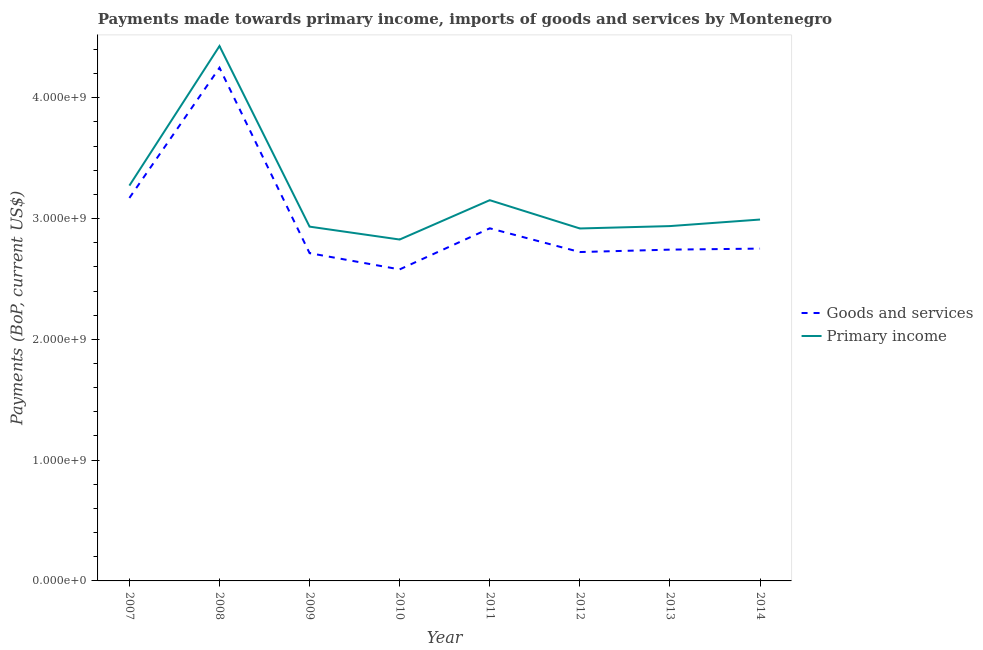What is the payments made towards primary income in 2008?
Your answer should be compact. 4.43e+09. Across all years, what is the maximum payments made towards goods and services?
Offer a terse response. 4.25e+09. Across all years, what is the minimum payments made towards goods and services?
Make the answer very short. 2.58e+09. What is the total payments made towards primary income in the graph?
Keep it short and to the point. 2.55e+1. What is the difference between the payments made towards goods and services in 2007 and that in 2008?
Provide a succinct answer. -1.08e+09. What is the difference between the payments made towards goods and services in 2013 and the payments made towards primary income in 2014?
Make the answer very short. -2.49e+08. What is the average payments made towards goods and services per year?
Provide a succinct answer. 2.98e+09. In the year 2013, what is the difference between the payments made towards primary income and payments made towards goods and services?
Keep it short and to the point. 1.95e+08. In how many years, is the payments made towards goods and services greater than 2200000000 US$?
Ensure brevity in your answer.  8. What is the ratio of the payments made towards goods and services in 2010 to that in 2013?
Your response must be concise. 0.94. What is the difference between the highest and the second highest payments made towards primary income?
Offer a very short reply. 1.16e+09. What is the difference between the highest and the lowest payments made towards goods and services?
Offer a very short reply. 1.67e+09. Does the payments made towards goods and services monotonically increase over the years?
Provide a short and direct response. No. How many lines are there?
Provide a short and direct response. 2. Are the values on the major ticks of Y-axis written in scientific E-notation?
Your response must be concise. Yes. How are the legend labels stacked?
Your answer should be compact. Vertical. What is the title of the graph?
Provide a succinct answer. Payments made towards primary income, imports of goods and services by Montenegro. Does "Netherlands" appear as one of the legend labels in the graph?
Make the answer very short. No. What is the label or title of the Y-axis?
Provide a short and direct response. Payments (BoP, current US$). What is the Payments (BoP, current US$) in Goods and services in 2007?
Keep it short and to the point. 3.17e+09. What is the Payments (BoP, current US$) in Primary income in 2007?
Keep it short and to the point. 3.27e+09. What is the Payments (BoP, current US$) in Goods and services in 2008?
Provide a short and direct response. 4.25e+09. What is the Payments (BoP, current US$) of Primary income in 2008?
Give a very brief answer. 4.43e+09. What is the Payments (BoP, current US$) in Goods and services in 2009?
Ensure brevity in your answer.  2.71e+09. What is the Payments (BoP, current US$) of Primary income in 2009?
Provide a succinct answer. 2.93e+09. What is the Payments (BoP, current US$) in Goods and services in 2010?
Your response must be concise. 2.58e+09. What is the Payments (BoP, current US$) of Primary income in 2010?
Keep it short and to the point. 2.83e+09. What is the Payments (BoP, current US$) of Goods and services in 2011?
Your response must be concise. 2.92e+09. What is the Payments (BoP, current US$) in Primary income in 2011?
Keep it short and to the point. 3.15e+09. What is the Payments (BoP, current US$) of Goods and services in 2012?
Make the answer very short. 2.72e+09. What is the Payments (BoP, current US$) in Primary income in 2012?
Provide a short and direct response. 2.92e+09. What is the Payments (BoP, current US$) of Goods and services in 2013?
Your answer should be compact. 2.74e+09. What is the Payments (BoP, current US$) in Primary income in 2013?
Make the answer very short. 2.94e+09. What is the Payments (BoP, current US$) of Goods and services in 2014?
Give a very brief answer. 2.75e+09. What is the Payments (BoP, current US$) in Primary income in 2014?
Your answer should be compact. 2.99e+09. Across all years, what is the maximum Payments (BoP, current US$) in Goods and services?
Make the answer very short. 4.25e+09. Across all years, what is the maximum Payments (BoP, current US$) of Primary income?
Provide a short and direct response. 4.43e+09. Across all years, what is the minimum Payments (BoP, current US$) of Goods and services?
Give a very brief answer. 2.58e+09. Across all years, what is the minimum Payments (BoP, current US$) in Primary income?
Provide a succinct answer. 2.83e+09. What is the total Payments (BoP, current US$) in Goods and services in the graph?
Your answer should be very brief. 2.38e+1. What is the total Payments (BoP, current US$) of Primary income in the graph?
Give a very brief answer. 2.55e+1. What is the difference between the Payments (BoP, current US$) in Goods and services in 2007 and that in 2008?
Give a very brief answer. -1.08e+09. What is the difference between the Payments (BoP, current US$) of Primary income in 2007 and that in 2008?
Keep it short and to the point. -1.16e+09. What is the difference between the Payments (BoP, current US$) of Goods and services in 2007 and that in 2009?
Give a very brief answer. 4.57e+08. What is the difference between the Payments (BoP, current US$) of Primary income in 2007 and that in 2009?
Ensure brevity in your answer.  3.40e+08. What is the difference between the Payments (BoP, current US$) of Goods and services in 2007 and that in 2010?
Provide a succinct answer. 5.92e+08. What is the difference between the Payments (BoP, current US$) in Primary income in 2007 and that in 2010?
Offer a very short reply. 4.46e+08. What is the difference between the Payments (BoP, current US$) in Goods and services in 2007 and that in 2011?
Provide a succinct answer. 2.51e+08. What is the difference between the Payments (BoP, current US$) in Primary income in 2007 and that in 2011?
Keep it short and to the point. 1.21e+08. What is the difference between the Payments (BoP, current US$) of Goods and services in 2007 and that in 2012?
Your answer should be very brief. 4.48e+08. What is the difference between the Payments (BoP, current US$) of Primary income in 2007 and that in 2012?
Your answer should be very brief. 3.55e+08. What is the difference between the Payments (BoP, current US$) in Goods and services in 2007 and that in 2013?
Offer a very short reply. 4.28e+08. What is the difference between the Payments (BoP, current US$) in Primary income in 2007 and that in 2013?
Offer a very short reply. 3.35e+08. What is the difference between the Payments (BoP, current US$) in Goods and services in 2007 and that in 2014?
Your response must be concise. 4.19e+08. What is the difference between the Payments (BoP, current US$) of Primary income in 2007 and that in 2014?
Give a very brief answer. 2.81e+08. What is the difference between the Payments (BoP, current US$) in Goods and services in 2008 and that in 2009?
Give a very brief answer. 1.53e+09. What is the difference between the Payments (BoP, current US$) of Primary income in 2008 and that in 2009?
Offer a very short reply. 1.50e+09. What is the difference between the Payments (BoP, current US$) in Goods and services in 2008 and that in 2010?
Make the answer very short. 1.67e+09. What is the difference between the Payments (BoP, current US$) in Primary income in 2008 and that in 2010?
Your response must be concise. 1.60e+09. What is the difference between the Payments (BoP, current US$) in Goods and services in 2008 and that in 2011?
Ensure brevity in your answer.  1.33e+09. What is the difference between the Payments (BoP, current US$) of Primary income in 2008 and that in 2011?
Provide a succinct answer. 1.28e+09. What is the difference between the Payments (BoP, current US$) in Goods and services in 2008 and that in 2012?
Keep it short and to the point. 1.53e+09. What is the difference between the Payments (BoP, current US$) in Primary income in 2008 and that in 2012?
Give a very brief answer. 1.51e+09. What is the difference between the Payments (BoP, current US$) in Goods and services in 2008 and that in 2013?
Provide a succinct answer. 1.51e+09. What is the difference between the Payments (BoP, current US$) in Primary income in 2008 and that in 2013?
Your response must be concise. 1.49e+09. What is the difference between the Payments (BoP, current US$) in Goods and services in 2008 and that in 2014?
Your response must be concise. 1.50e+09. What is the difference between the Payments (BoP, current US$) in Primary income in 2008 and that in 2014?
Provide a succinct answer. 1.44e+09. What is the difference between the Payments (BoP, current US$) of Goods and services in 2009 and that in 2010?
Ensure brevity in your answer.  1.34e+08. What is the difference between the Payments (BoP, current US$) of Primary income in 2009 and that in 2010?
Give a very brief answer. 1.07e+08. What is the difference between the Payments (BoP, current US$) of Goods and services in 2009 and that in 2011?
Provide a short and direct response. -2.06e+08. What is the difference between the Payments (BoP, current US$) of Primary income in 2009 and that in 2011?
Offer a very short reply. -2.19e+08. What is the difference between the Payments (BoP, current US$) in Goods and services in 2009 and that in 2012?
Provide a short and direct response. -9.23e+06. What is the difference between the Payments (BoP, current US$) in Primary income in 2009 and that in 2012?
Ensure brevity in your answer.  1.51e+07. What is the difference between the Payments (BoP, current US$) of Goods and services in 2009 and that in 2013?
Your response must be concise. -2.92e+07. What is the difference between the Payments (BoP, current US$) in Primary income in 2009 and that in 2013?
Make the answer very short. -4.58e+06. What is the difference between the Payments (BoP, current US$) of Goods and services in 2009 and that in 2014?
Make the answer very short. -3.77e+07. What is the difference between the Payments (BoP, current US$) in Primary income in 2009 and that in 2014?
Offer a terse response. -5.88e+07. What is the difference between the Payments (BoP, current US$) of Goods and services in 2010 and that in 2011?
Your response must be concise. -3.40e+08. What is the difference between the Payments (BoP, current US$) in Primary income in 2010 and that in 2011?
Keep it short and to the point. -3.26e+08. What is the difference between the Payments (BoP, current US$) in Goods and services in 2010 and that in 2012?
Keep it short and to the point. -1.44e+08. What is the difference between the Payments (BoP, current US$) of Primary income in 2010 and that in 2012?
Offer a terse response. -9.16e+07. What is the difference between the Payments (BoP, current US$) in Goods and services in 2010 and that in 2013?
Your answer should be compact. -1.64e+08. What is the difference between the Payments (BoP, current US$) in Primary income in 2010 and that in 2013?
Your answer should be very brief. -1.11e+08. What is the difference between the Payments (BoP, current US$) of Goods and services in 2010 and that in 2014?
Provide a short and direct response. -1.72e+08. What is the difference between the Payments (BoP, current US$) of Primary income in 2010 and that in 2014?
Provide a succinct answer. -1.66e+08. What is the difference between the Payments (BoP, current US$) in Goods and services in 2011 and that in 2012?
Keep it short and to the point. 1.96e+08. What is the difference between the Payments (BoP, current US$) of Primary income in 2011 and that in 2012?
Offer a terse response. 2.34e+08. What is the difference between the Payments (BoP, current US$) in Goods and services in 2011 and that in 2013?
Ensure brevity in your answer.  1.77e+08. What is the difference between the Payments (BoP, current US$) of Primary income in 2011 and that in 2013?
Your response must be concise. 2.14e+08. What is the difference between the Payments (BoP, current US$) in Goods and services in 2011 and that in 2014?
Keep it short and to the point. 1.68e+08. What is the difference between the Payments (BoP, current US$) in Primary income in 2011 and that in 2014?
Provide a succinct answer. 1.60e+08. What is the difference between the Payments (BoP, current US$) in Goods and services in 2012 and that in 2013?
Your response must be concise. -1.99e+07. What is the difference between the Payments (BoP, current US$) of Primary income in 2012 and that in 2013?
Offer a terse response. -1.97e+07. What is the difference between the Payments (BoP, current US$) of Goods and services in 2012 and that in 2014?
Keep it short and to the point. -2.85e+07. What is the difference between the Payments (BoP, current US$) of Primary income in 2012 and that in 2014?
Ensure brevity in your answer.  -7.39e+07. What is the difference between the Payments (BoP, current US$) in Goods and services in 2013 and that in 2014?
Your response must be concise. -8.57e+06. What is the difference between the Payments (BoP, current US$) in Primary income in 2013 and that in 2014?
Make the answer very short. -5.42e+07. What is the difference between the Payments (BoP, current US$) of Goods and services in 2007 and the Payments (BoP, current US$) of Primary income in 2008?
Your response must be concise. -1.26e+09. What is the difference between the Payments (BoP, current US$) of Goods and services in 2007 and the Payments (BoP, current US$) of Primary income in 2009?
Provide a succinct answer. 2.38e+08. What is the difference between the Payments (BoP, current US$) in Goods and services in 2007 and the Payments (BoP, current US$) in Primary income in 2010?
Make the answer very short. 3.44e+08. What is the difference between the Payments (BoP, current US$) in Goods and services in 2007 and the Payments (BoP, current US$) in Primary income in 2011?
Offer a very short reply. 1.85e+07. What is the difference between the Payments (BoP, current US$) of Goods and services in 2007 and the Payments (BoP, current US$) of Primary income in 2012?
Offer a terse response. 2.53e+08. What is the difference between the Payments (BoP, current US$) in Goods and services in 2007 and the Payments (BoP, current US$) in Primary income in 2013?
Give a very brief answer. 2.33e+08. What is the difference between the Payments (BoP, current US$) in Goods and services in 2007 and the Payments (BoP, current US$) in Primary income in 2014?
Provide a short and direct response. 1.79e+08. What is the difference between the Payments (BoP, current US$) in Goods and services in 2008 and the Payments (BoP, current US$) in Primary income in 2009?
Your answer should be very brief. 1.32e+09. What is the difference between the Payments (BoP, current US$) in Goods and services in 2008 and the Payments (BoP, current US$) in Primary income in 2010?
Your answer should be compact. 1.42e+09. What is the difference between the Payments (BoP, current US$) of Goods and services in 2008 and the Payments (BoP, current US$) of Primary income in 2011?
Provide a succinct answer. 1.10e+09. What is the difference between the Payments (BoP, current US$) of Goods and services in 2008 and the Payments (BoP, current US$) of Primary income in 2012?
Make the answer very short. 1.33e+09. What is the difference between the Payments (BoP, current US$) of Goods and services in 2008 and the Payments (BoP, current US$) of Primary income in 2013?
Provide a succinct answer. 1.31e+09. What is the difference between the Payments (BoP, current US$) in Goods and services in 2008 and the Payments (BoP, current US$) in Primary income in 2014?
Provide a succinct answer. 1.26e+09. What is the difference between the Payments (BoP, current US$) in Goods and services in 2009 and the Payments (BoP, current US$) in Primary income in 2010?
Your answer should be very brief. -1.13e+08. What is the difference between the Payments (BoP, current US$) in Goods and services in 2009 and the Payments (BoP, current US$) in Primary income in 2011?
Offer a very short reply. -4.39e+08. What is the difference between the Payments (BoP, current US$) in Goods and services in 2009 and the Payments (BoP, current US$) in Primary income in 2012?
Provide a short and direct response. -2.04e+08. What is the difference between the Payments (BoP, current US$) of Goods and services in 2009 and the Payments (BoP, current US$) of Primary income in 2013?
Give a very brief answer. -2.24e+08. What is the difference between the Payments (BoP, current US$) of Goods and services in 2009 and the Payments (BoP, current US$) of Primary income in 2014?
Give a very brief answer. -2.78e+08. What is the difference between the Payments (BoP, current US$) of Goods and services in 2010 and the Payments (BoP, current US$) of Primary income in 2011?
Make the answer very short. -5.73e+08. What is the difference between the Payments (BoP, current US$) in Goods and services in 2010 and the Payments (BoP, current US$) in Primary income in 2012?
Offer a very short reply. -3.39e+08. What is the difference between the Payments (BoP, current US$) of Goods and services in 2010 and the Payments (BoP, current US$) of Primary income in 2013?
Give a very brief answer. -3.59e+08. What is the difference between the Payments (BoP, current US$) in Goods and services in 2010 and the Payments (BoP, current US$) in Primary income in 2014?
Your answer should be very brief. -4.13e+08. What is the difference between the Payments (BoP, current US$) of Goods and services in 2011 and the Payments (BoP, current US$) of Primary income in 2012?
Offer a very short reply. 1.32e+06. What is the difference between the Payments (BoP, current US$) of Goods and services in 2011 and the Payments (BoP, current US$) of Primary income in 2013?
Ensure brevity in your answer.  -1.84e+07. What is the difference between the Payments (BoP, current US$) in Goods and services in 2011 and the Payments (BoP, current US$) in Primary income in 2014?
Provide a short and direct response. -7.26e+07. What is the difference between the Payments (BoP, current US$) in Goods and services in 2012 and the Payments (BoP, current US$) in Primary income in 2013?
Make the answer very short. -2.15e+08. What is the difference between the Payments (BoP, current US$) in Goods and services in 2012 and the Payments (BoP, current US$) in Primary income in 2014?
Offer a terse response. -2.69e+08. What is the difference between the Payments (BoP, current US$) in Goods and services in 2013 and the Payments (BoP, current US$) in Primary income in 2014?
Make the answer very short. -2.49e+08. What is the average Payments (BoP, current US$) of Goods and services per year?
Your response must be concise. 2.98e+09. What is the average Payments (BoP, current US$) of Primary income per year?
Your answer should be very brief. 3.18e+09. In the year 2007, what is the difference between the Payments (BoP, current US$) of Goods and services and Payments (BoP, current US$) of Primary income?
Provide a succinct answer. -1.02e+08. In the year 2008, what is the difference between the Payments (BoP, current US$) of Goods and services and Payments (BoP, current US$) of Primary income?
Offer a terse response. -1.80e+08. In the year 2009, what is the difference between the Payments (BoP, current US$) of Goods and services and Payments (BoP, current US$) of Primary income?
Offer a terse response. -2.20e+08. In the year 2010, what is the difference between the Payments (BoP, current US$) of Goods and services and Payments (BoP, current US$) of Primary income?
Your answer should be very brief. -2.47e+08. In the year 2011, what is the difference between the Payments (BoP, current US$) of Goods and services and Payments (BoP, current US$) of Primary income?
Keep it short and to the point. -2.33e+08. In the year 2012, what is the difference between the Payments (BoP, current US$) of Goods and services and Payments (BoP, current US$) of Primary income?
Keep it short and to the point. -1.95e+08. In the year 2013, what is the difference between the Payments (BoP, current US$) of Goods and services and Payments (BoP, current US$) of Primary income?
Offer a terse response. -1.95e+08. In the year 2014, what is the difference between the Payments (BoP, current US$) of Goods and services and Payments (BoP, current US$) of Primary income?
Provide a short and direct response. -2.41e+08. What is the ratio of the Payments (BoP, current US$) of Goods and services in 2007 to that in 2008?
Your response must be concise. 0.75. What is the ratio of the Payments (BoP, current US$) of Primary income in 2007 to that in 2008?
Give a very brief answer. 0.74. What is the ratio of the Payments (BoP, current US$) in Goods and services in 2007 to that in 2009?
Offer a very short reply. 1.17. What is the ratio of the Payments (BoP, current US$) in Primary income in 2007 to that in 2009?
Your answer should be compact. 1.12. What is the ratio of the Payments (BoP, current US$) in Goods and services in 2007 to that in 2010?
Provide a succinct answer. 1.23. What is the ratio of the Payments (BoP, current US$) of Primary income in 2007 to that in 2010?
Your response must be concise. 1.16. What is the ratio of the Payments (BoP, current US$) of Goods and services in 2007 to that in 2011?
Give a very brief answer. 1.09. What is the ratio of the Payments (BoP, current US$) in Primary income in 2007 to that in 2011?
Offer a very short reply. 1.04. What is the ratio of the Payments (BoP, current US$) of Goods and services in 2007 to that in 2012?
Your answer should be very brief. 1.16. What is the ratio of the Payments (BoP, current US$) of Primary income in 2007 to that in 2012?
Provide a short and direct response. 1.12. What is the ratio of the Payments (BoP, current US$) of Goods and services in 2007 to that in 2013?
Make the answer very short. 1.16. What is the ratio of the Payments (BoP, current US$) of Primary income in 2007 to that in 2013?
Offer a terse response. 1.11. What is the ratio of the Payments (BoP, current US$) of Goods and services in 2007 to that in 2014?
Ensure brevity in your answer.  1.15. What is the ratio of the Payments (BoP, current US$) of Primary income in 2007 to that in 2014?
Provide a short and direct response. 1.09. What is the ratio of the Payments (BoP, current US$) in Goods and services in 2008 to that in 2009?
Make the answer very short. 1.57. What is the ratio of the Payments (BoP, current US$) of Primary income in 2008 to that in 2009?
Ensure brevity in your answer.  1.51. What is the ratio of the Payments (BoP, current US$) of Goods and services in 2008 to that in 2010?
Keep it short and to the point. 1.65. What is the ratio of the Payments (BoP, current US$) of Primary income in 2008 to that in 2010?
Your response must be concise. 1.57. What is the ratio of the Payments (BoP, current US$) in Goods and services in 2008 to that in 2011?
Your response must be concise. 1.46. What is the ratio of the Payments (BoP, current US$) in Primary income in 2008 to that in 2011?
Offer a terse response. 1.4. What is the ratio of the Payments (BoP, current US$) of Goods and services in 2008 to that in 2012?
Provide a short and direct response. 1.56. What is the ratio of the Payments (BoP, current US$) in Primary income in 2008 to that in 2012?
Provide a short and direct response. 1.52. What is the ratio of the Payments (BoP, current US$) in Goods and services in 2008 to that in 2013?
Offer a very short reply. 1.55. What is the ratio of the Payments (BoP, current US$) of Primary income in 2008 to that in 2013?
Your answer should be very brief. 1.51. What is the ratio of the Payments (BoP, current US$) of Goods and services in 2008 to that in 2014?
Your response must be concise. 1.54. What is the ratio of the Payments (BoP, current US$) in Primary income in 2008 to that in 2014?
Provide a succinct answer. 1.48. What is the ratio of the Payments (BoP, current US$) of Goods and services in 2009 to that in 2010?
Offer a very short reply. 1.05. What is the ratio of the Payments (BoP, current US$) in Primary income in 2009 to that in 2010?
Keep it short and to the point. 1.04. What is the ratio of the Payments (BoP, current US$) in Goods and services in 2009 to that in 2011?
Offer a terse response. 0.93. What is the ratio of the Payments (BoP, current US$) in Primary income in 2009 to that in 2011?
Make the answer very short. 0.93. What is the ratio of the Payments (BoP, current US$) in Goods and services in 2009 to that in 2014?
Make the answer very short. 0.99. What is the ratio of the Payments (BoP, current US$) of Primary income in 2009 to that in 2014?
Offer a terse response. 0.98. What is the ratio of the Payments (BoP, current US$) of Goods and services in 2010 to that in 2011?
Provide a succinct answer. 0.88. What is the ratio of the Payments (BoP, current US$) in Primary income in 2010 to that in 2011?
Your answer should be very brief. 0.9. What is the ratio of the Payments (BoP, current US$) of Goods and services in 2010 to that in 2012?
Your answer should be very brief. 0.95. What is the ratio of the Payments (BoP, current US$) in Primary income in 2010 to that in 2012?
Offer a very short reply. 0.97. What is the ratio of the Payments (BoP, current US$) of Goods and services in 2010 to that in 2013?
Offer a terse response. 0.94. What is the ratio of the Payments (BoP, current US$) in Primary income in 2010 to that in 2013?
Your response must be concise. 0.96. What is the ratio of the Payments (BoP, current US$) in Goods and services in 2010 to that in 2014?
Make the answer very short. 0.94. What is the ratio of the Payments (BoP, current US$) in Primary income in 2010 to that in 2014?
Offer a terse response. 0.94. What is the ratio of the Payments (BoP, current US$) in Goods and services in 2011 to that in 2012?
Offer a terse response. 1.07. What is the ratio of the Payments (BoP, current US$) of Primary income in 2011 to that in 2012?
Your answer should be compact. 1.08. What is the ratio of the Payments (BoP, current US$) of Goods and services in 2011 to that in 2013?
Provide a succinct answer. 1.06. What is the ratio of the Payments (BoP, current US$) in Primary income in 2011 to that in 2013?
Give a very brief answer. 1.07. What is the ratio of the Payments (BoP, current US$) of Goods and services in 2011 to that in 2014?
Keep it short and to the point. 1.06. What is the ratio of the Payments (BoP, current US$) in Primary income in 2011 to that in 2014?
Ensure brevity in your answer.  1.05. What is the ratio of the Payments (BoP, current US$) of Goods and services in 2012 to that in 2013?
Make the answer very short. 0.99. What is the ratio of the Payments (BoP, current US$) in Primary income in 2012 to that in 2013?
Provide a short and direct response. 0.99. What is the ratio of the Payments (BoP, current US$) in Goods and services in 2012 to that in 2014?
Keep it short and to the point. 0.99. What is the ratio of the Payments (BoP, current US$) of Primary income in 2012 to that in 2014?
Your response must be concise. 0.98. What is the ratio of the Payments (BoP, current US$) of Goods and services in 2013 to that in 2014?
Provide a short and direct response. 1. What is the ratio of the Payments (BoP, current US$) in Primary income in 2013 to that in 2014?
Offer a very short reply. 0.98. What is the difference between the highest and the second highest Payments (BoP, current US$) of Goods and services?
Offer a very short reply. 1.08e+09. What is the difference between the highest and the second highest Payments (BoP, current US$) of Primary income?
Keep it short and to the point. 1.16e+09. What is the difference between the highest and the lowest Payments (BoP, current US$) of Goods and services?
Your answer should be compact. 1.67e+09. What is the difference between the highest and the lowest Payments (BoP, current US$) in Primary income?
Your answer should be compact. 1.60e+09. 